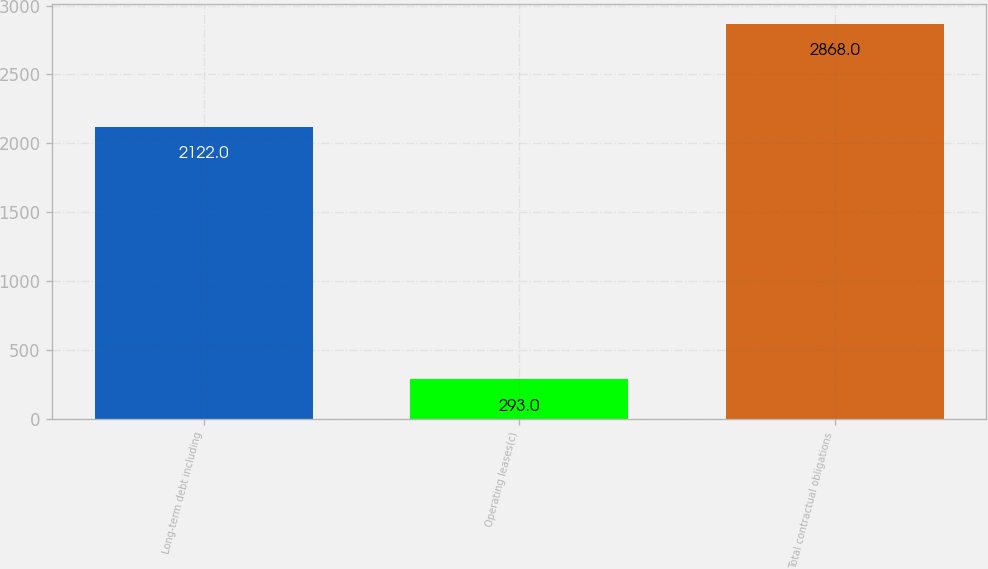<chart> <loc_0><loc_0><loc_500><loc_500><bar_chart><fcel>Long-term debt including<fcel>Operating leases(c)<fcel>Total contractual obligations<nl><fcel>2122<fcel>293<fcel>2868<nl></chart> 